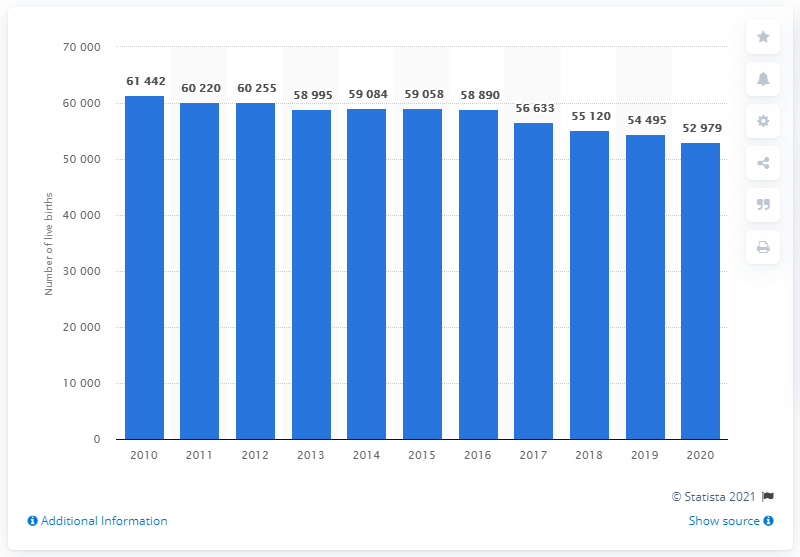Outline some significant characteristics in this image. In 2010, the highest number of live births in Norway was 61,442. In 2020, there were 52,979 live births in Norway. 